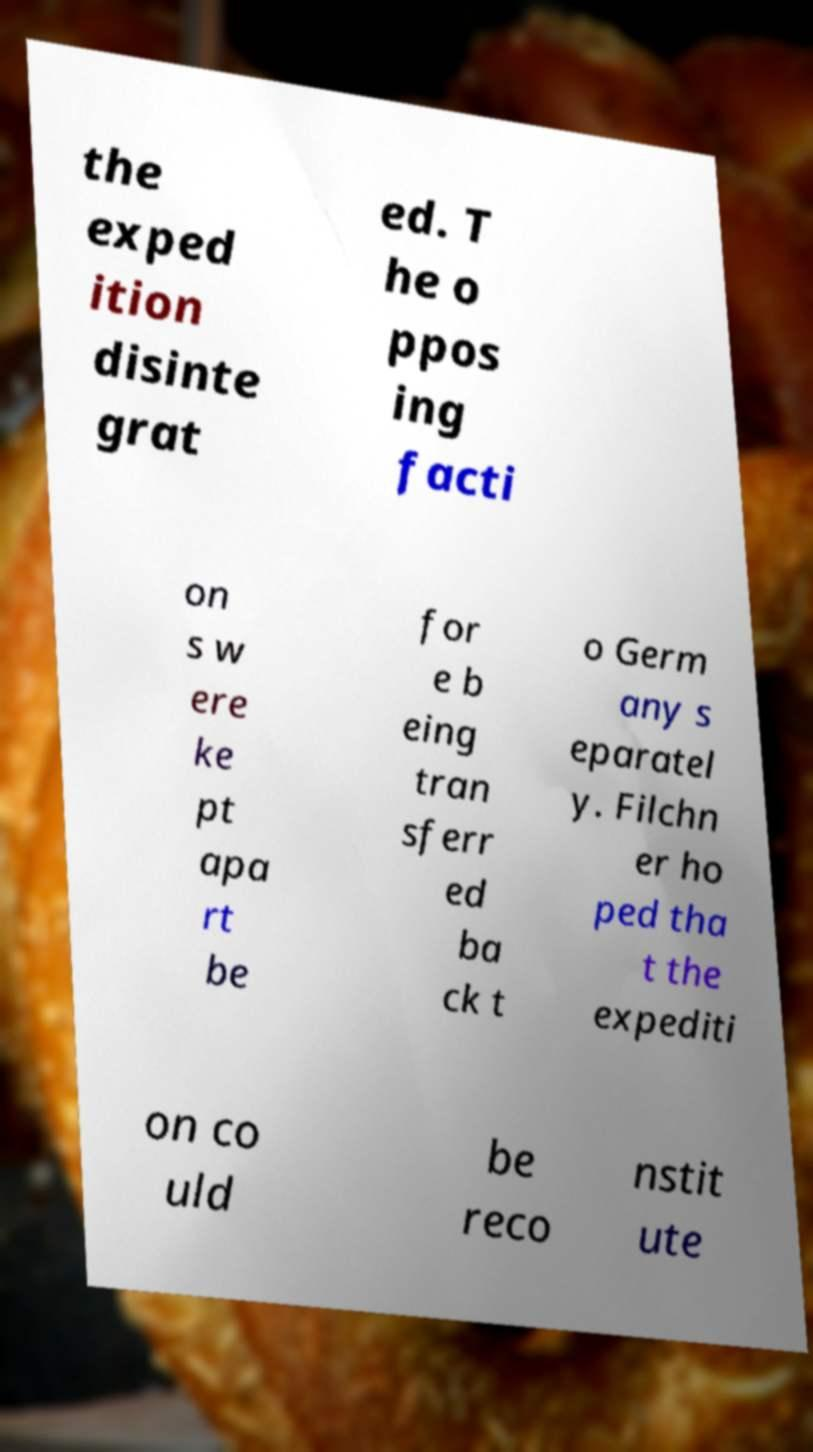Could you assist in decoding the text presented in this image and type it out clearly? the exped ition disinte grat ed. T he o ppos ing facti on s w ere ke pt apa rt be for e b eing tran sferr ed ba ck t o Germ any s eparatel y. Filchn er ho ped tha t the expediti on co uld be reco nstit ute 